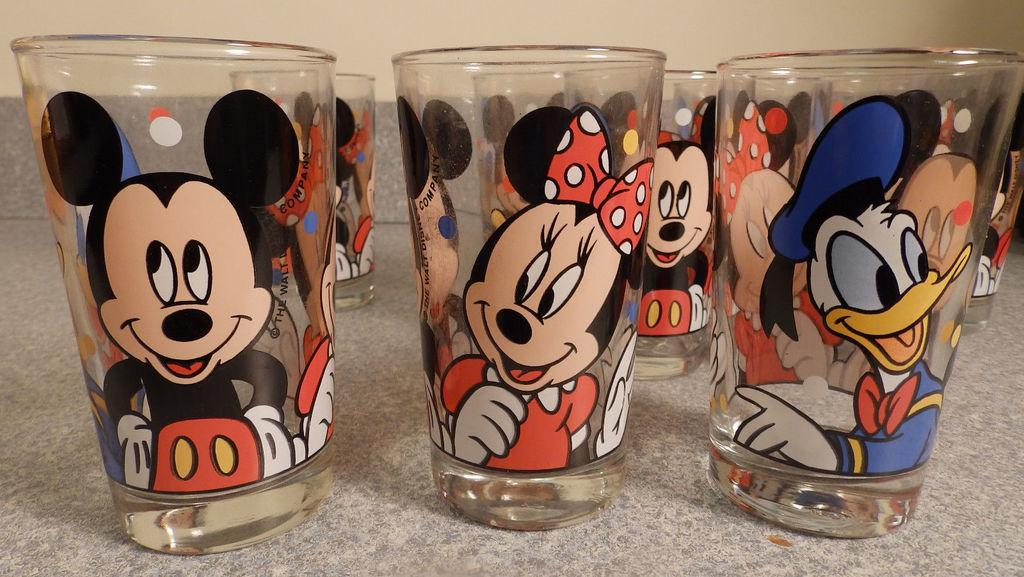What objects are on the floor in the image? There are glasses on the floor in the image. What is depicted on the glasses? Photos of cartoon characters are on the glasses. What can be seen in the background of the image? There is a wall visible in the background of the image. Where is the rifle placed in the image? There is no rifle present in the image. What type of cushion is on the floor next to the glasses? There is no cushion mentioned in the provided facts, so we cannot answer this question. 